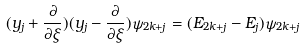<formula> <loc_0><loc_0><loc_500><loc_500>( y _ { j } + \frac { \partial } { \partial \xi } ) ( y _ { j } - \frac { \partial } { \partial \xi } ) \psi _ { 2 k + j } = ( E _ { 2 k + j } - E _ { j } ) \psi _ { 2 k + j }</formula> 